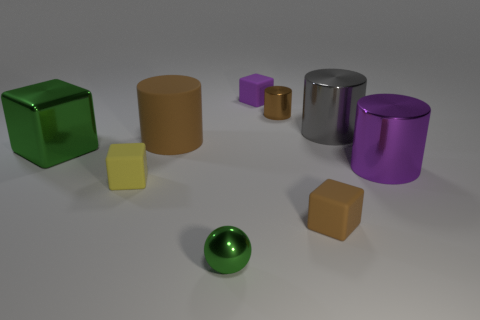Add 1 tiny green metallic objects. How many objects exist? 10 Subtract all yellow blocks. How many blocks are left? 3 Subtract 0 purple spheres. How many objects are left? 9 Subtract all cylinders. How many objects are left? 5 Subtract 1 spheres. How many spheres are left? 0 Subtract all brown cubes. Subtract all red cylinders. How many cubes are left? 3 Subtract all brown cubes. How many cyan spheres are left? 0 Subtract all large yellow matte spheres. Subtract all tiny metal balls. How many objects are left? 8 Add 2 tiny metallic objects. How many tiny metallic objects are left? 4 Add 7 tiny brown matte spheres. How many tiny brown matte spheres exist? 7 